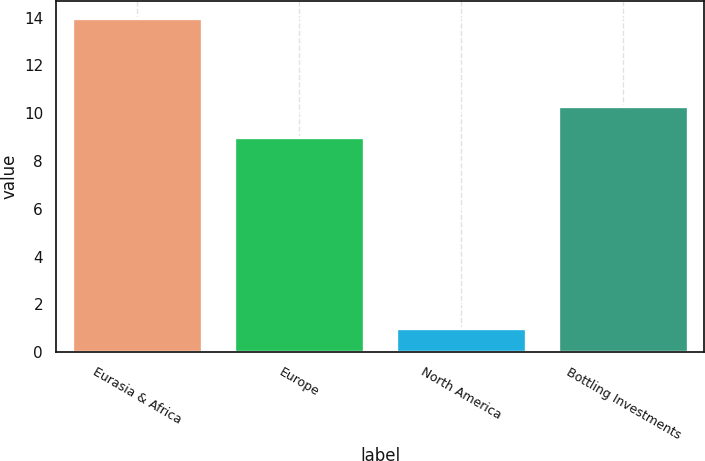<chart> <loc_0><loc_0><loc_500><loc_500><bar_chart><fcel>Eurasia & Africa<fcel>Europe<fcel>North America<fcel>Bottling Investments<nl><fcel>14<fcel>9<fcel>1<fcel>10.3<nl></chart> 